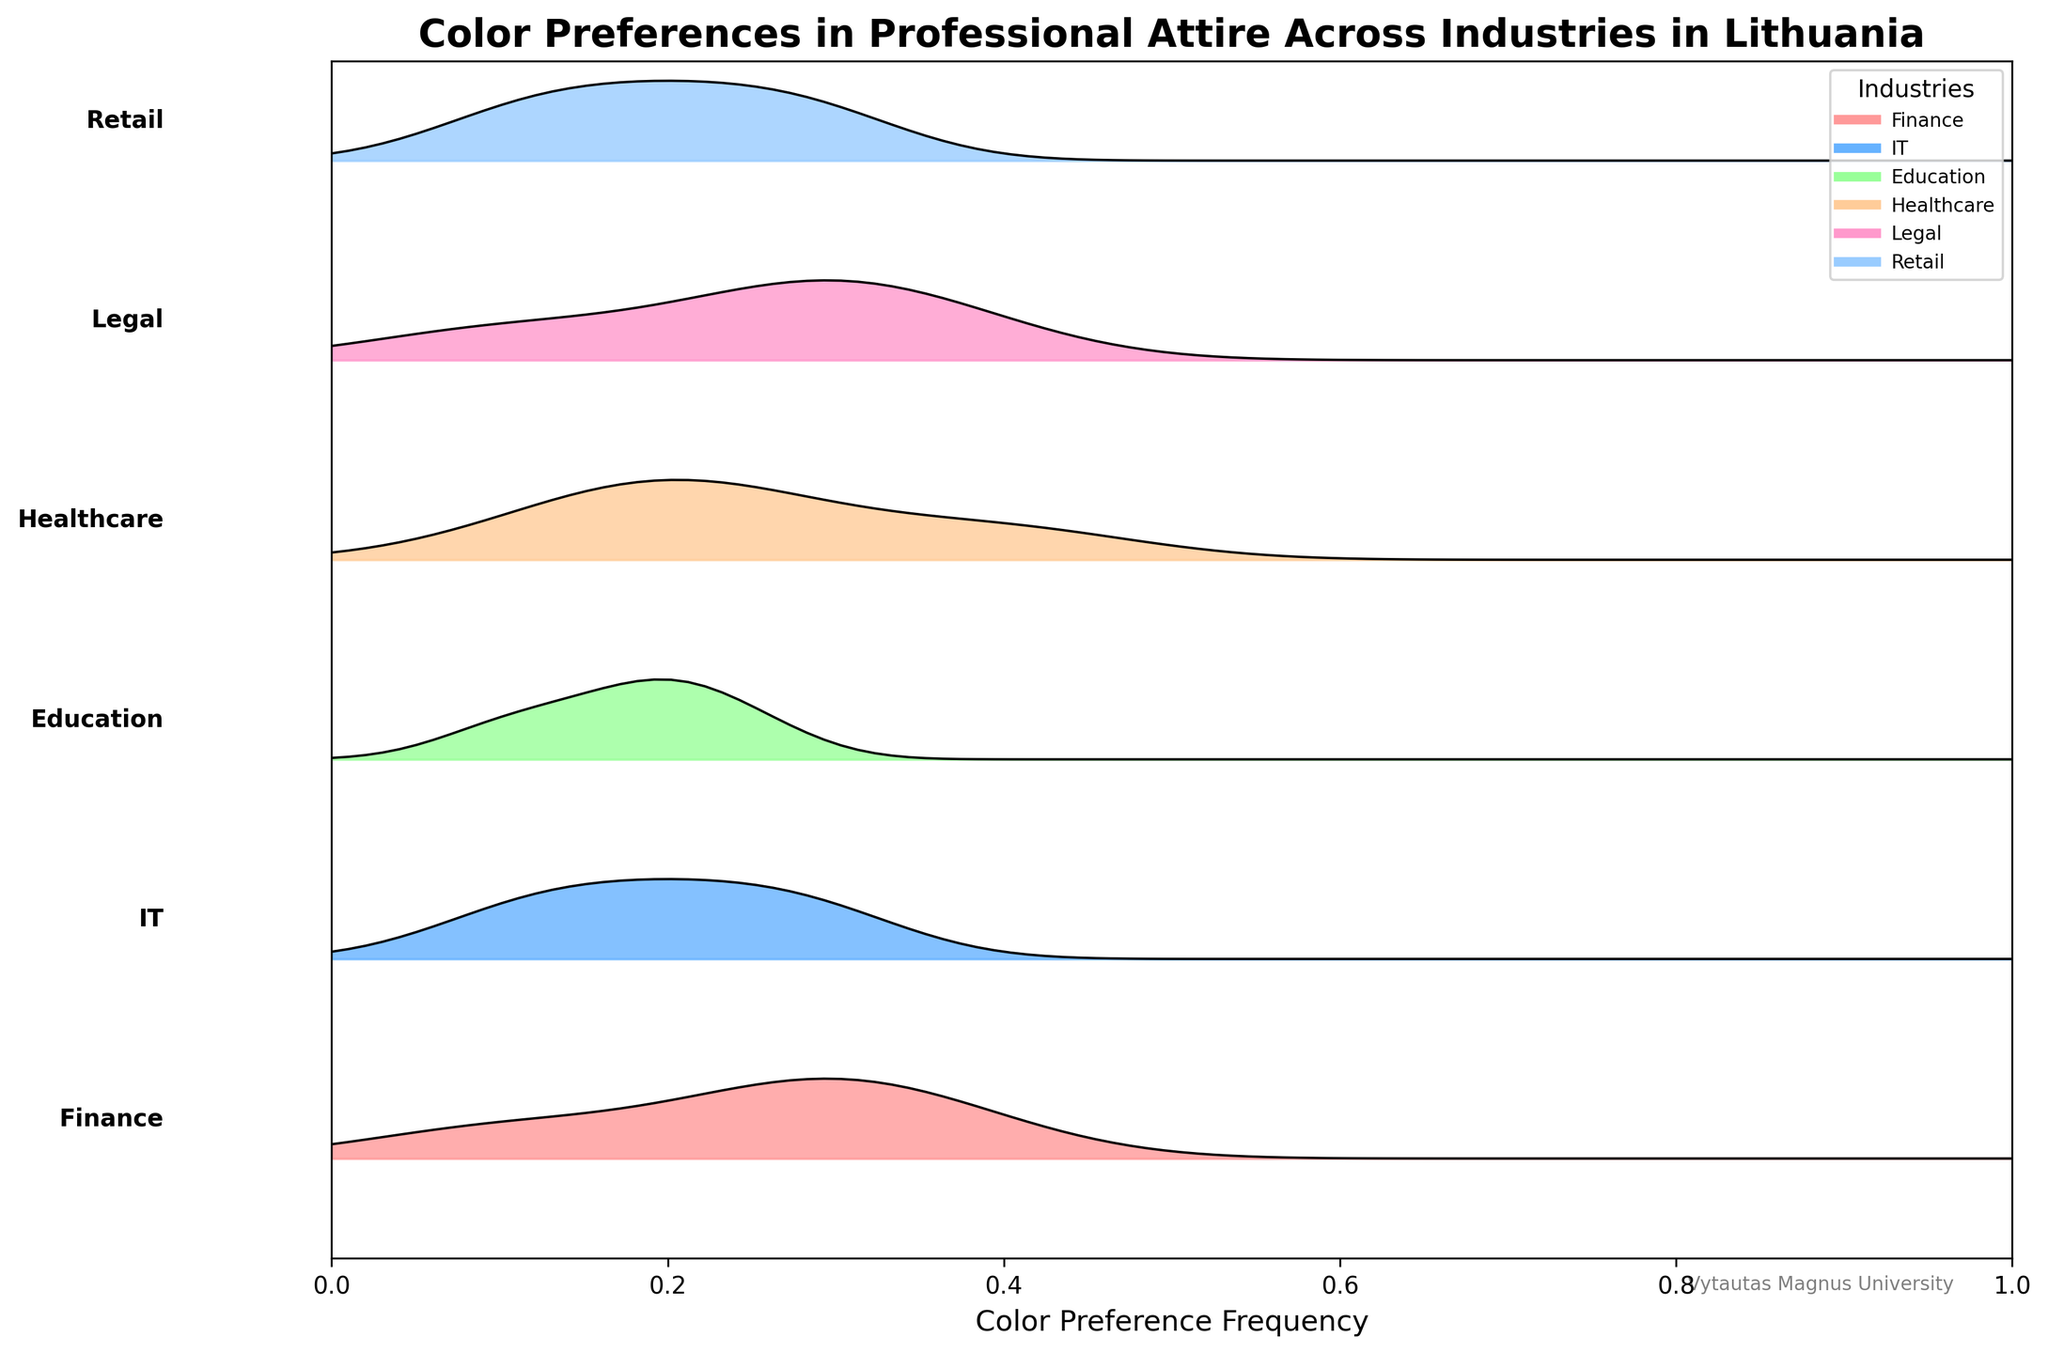What is the title of the Ridgeline plot? The title of the plot is clearly written at the top and often provides a summary description of the data being visualized.
Answer: Color Preferences in Professional Attire Across Industries in Lithuania What is the most preferred color in the Finance industry based on frequency? By looking at the Finance section of the plot, we can identify the color that has the highest peak.
Answer: Navy Blue Which industry has the highest preference for White color? By comparing the different industry plots, you can see which one has the highest frequency peak for the White color.
Answer: Healthcare In the IT industry, which color has a higher frequency, Black or White? Look at the IT section in the plot and compare the heights of the peaks for Black and White colors.
Answer: Black Which industry shows the most diverse range of color preferences? Different ranges can be observed by noticing the spread and number of peaks within each industry's section. The industry with the most colors indicated might be considered the most diverse.
Answer: IT How does the preference for Navy Blue in the Retail industry compare to the Legal industry? Compare the heights of the peaks for Navy Blue in the Retail and Legal industry sections to see which is higher.
Answer: Lower in Retail than in Legal What is the least preferred color in the Education industry? In the Education section, identify the color with the lowest frequency peak.
Answer: Maroon How many industries are represented in the Ridgeline plot? The number of unique industries can be seen by looking at the different labeled sections in the plot.
Answer: 6 Which industry has the smallest peak, indicating the least preference for a specific color, and which color is it? By scanning through all the sections, identify the smallest peak in any industry.
Answer: Legal, White Is the frequency of Burgundy higher in the IT industry or the Education industry? Look at the heights of the peaks for Burgundy in both IT and Education sections to determine which one is higher.
Answer: IT 